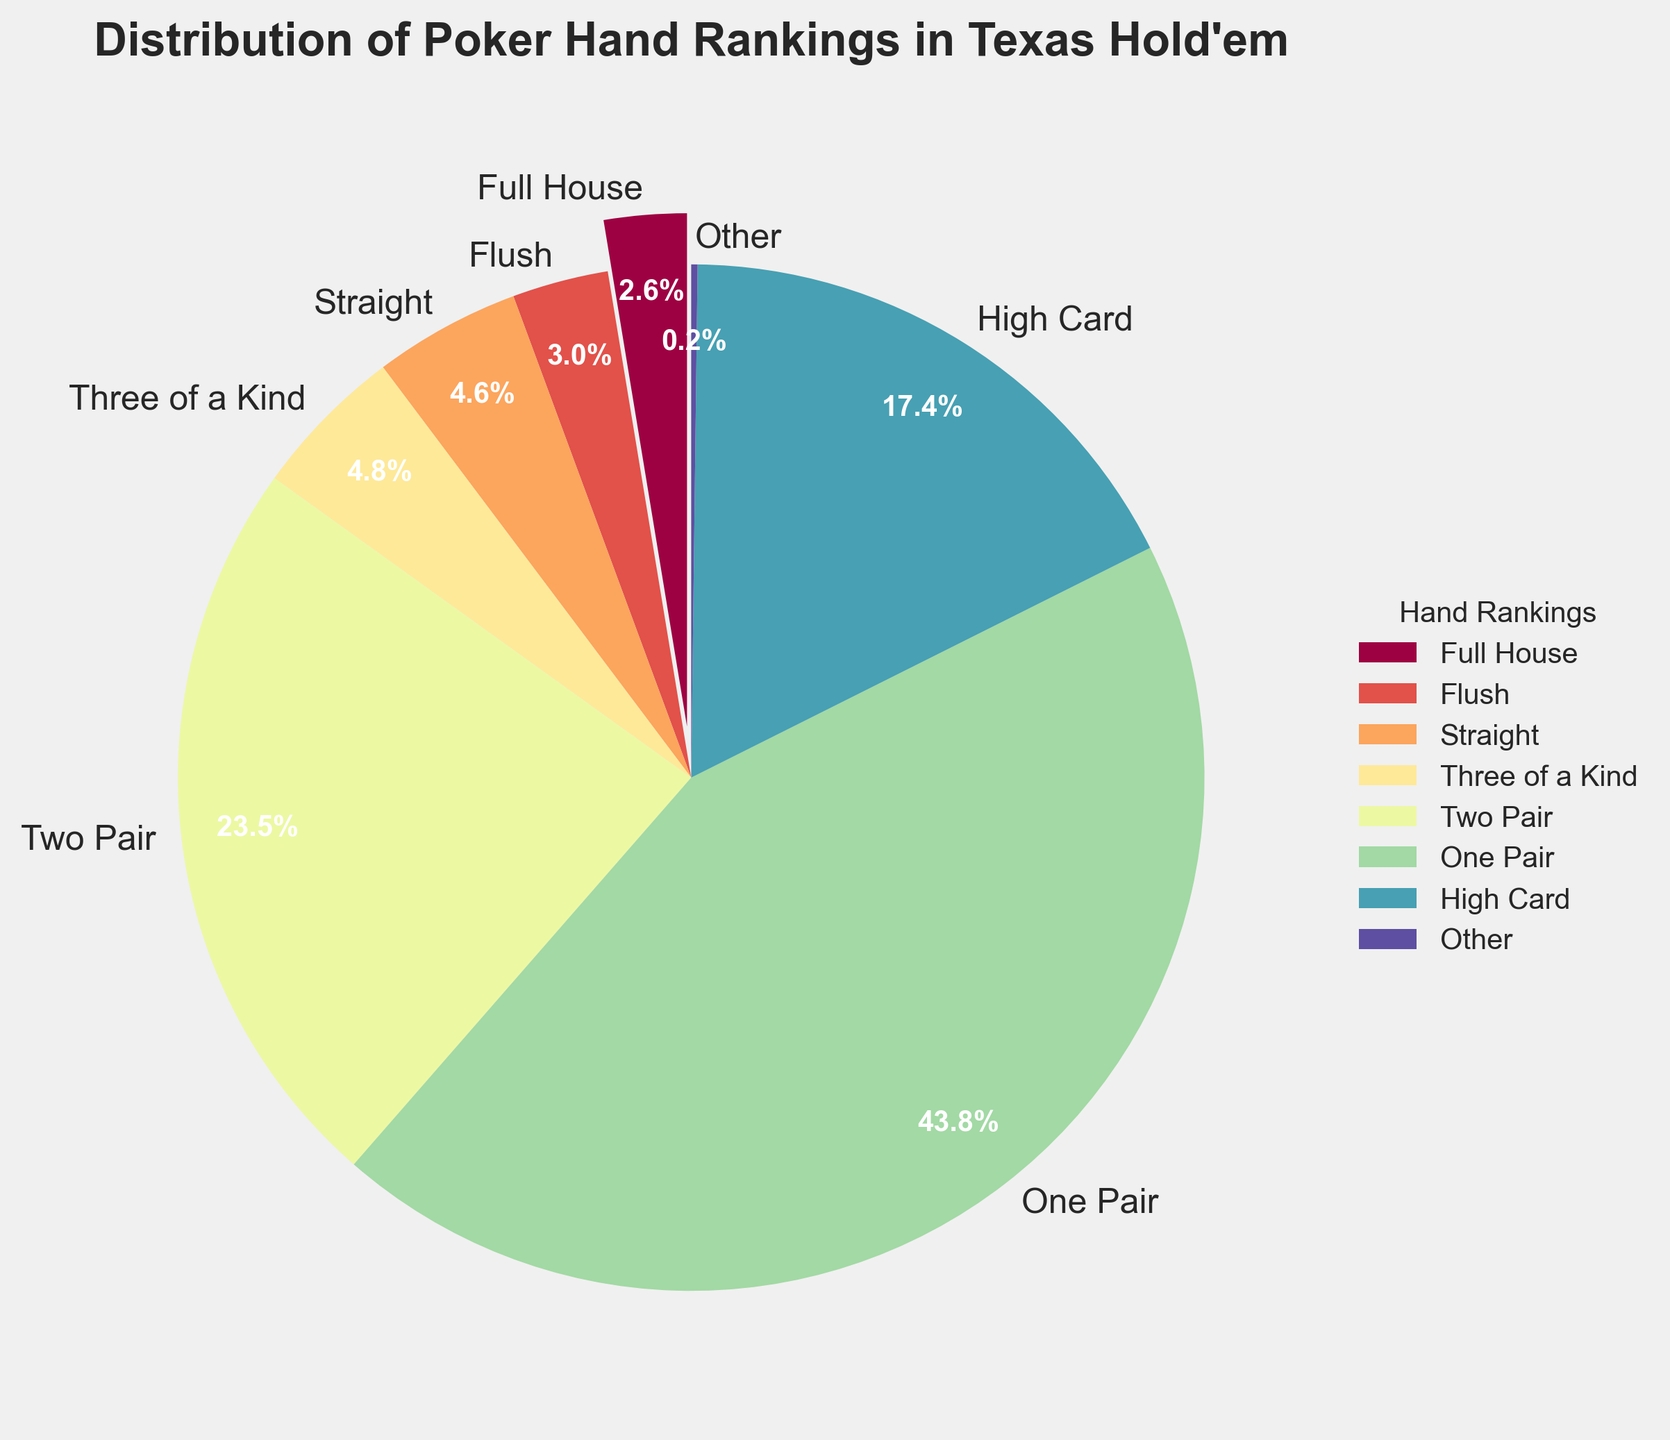What's the most common poker hand ranking in Texas Hold'em? The pie chart shows that the "One Pair" segment is the largest, indicating it's the most common hand ranking.
Answer: One Pair What is the combined percentage of "Two Pair" and "High Card" hands? From the chart, "Two Pair" represents 23.50%, and "High Card" represents 17.41%. Adding these percentages gives 23.50% + 17.41% = 40.91%.
Answer: 40.91% Which hand ranking is less common: "Three of a Kind" or "Straight"? The pie chart shows that "Three of a Kind" accounts for 4.83%, while "Straight" accounts for 4.62%. Thus, "Straight" is less common.
Answer: Straight What percentage of hands are ranked either as "Royal Flush" or "Straight Flush"? The "Royal Flush" segment accounts for 0.0032% and the "Straight Flush" accounts for 0.0279%. Adding these, 0.0032% + 0.0279% = 0.0311%.
Answer: 0.0311% How does the frequency of "Full House" compare to the frequency of "Flush"? The pie chart shows "Full House" at 2.60% and "Flush" at 3.03%. Therefore, "Flush" is more frequent than "Full House".
Answer: Flush is more frequent What is the percentage of hands that don't fall under any of the major hand rankings displayed individually? The percentage of "Other" in the pie chart, which represents combined smaller frequencies, is 0.20%.
Answer: 0.20% What is the difference in percentages between "Four of a Kind" and "Full House"? "Four of a Kind" is 0.168%, and "Full House" is 2.60%. Subtracting these percentages, we get 2.60% - 0.168% = 2.432%.
Answer: 2.432% If you add the percentages of "One Pair" and "Three of a Kind," what total percentage do you get? "One Pair" is 43.80%, and "Three of a Kind" is 4.83%. Adding these, 43.80% + 4.83% = 48.63%.
Answer: 48.63% Visualize the colors used in the chart and describe which hand ranking is represented by the most vivid color. The "One Pair" segment is exaggerated towards the viewer with a slight explosion and is represented by the most vivid color, indicating its significance as the most common ranking.
Answer: One Pair 